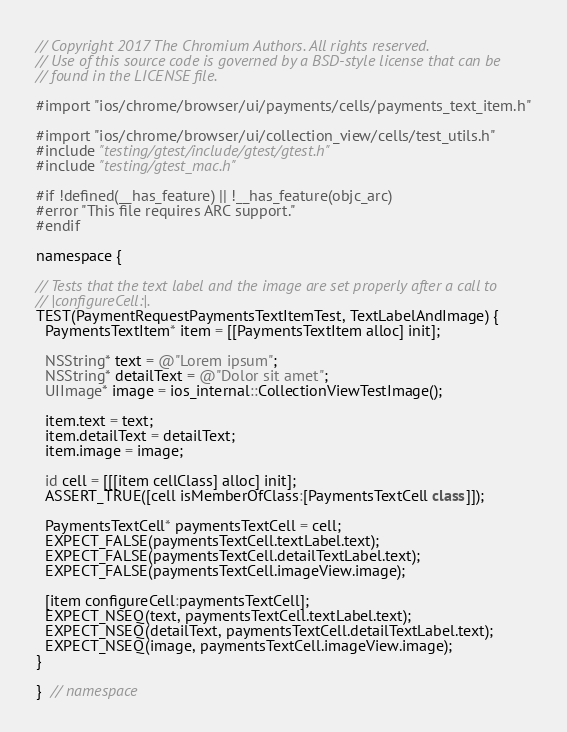Convert code to text. <code><loc_0><loc_0><loc_500><loc_500><_ObjectiveC_>// Copyright 2017 The Chromium Authors. All rights reserved.
// Use of this source code is governed by a BSD-style license that can be
// found in the LICENSE file.

#import "ios/chrome/browser/ui/payments/cells/payments_text_item.h"

#import "ios/chrome/browser/ui/collection_view/cells/test_utils.h"
#include "testing/gtest/include/gtest/gtest.h"
#include "testing/gtest_mac.h"

#if !defined(__has_feature) || !__has_feature(objc_arc)
#error "This file requires ARC support."
#endif

namespace {

// Tests that the text label and the image are set properly after a call to
// |configureCell:|.
TEST(PaymentRequestPaymentsTextItemTest, TextLabelAndImage) {
  PaymentsTextItem* item = [[PaymentsTextItem alloc] init];

  NSString* text = @"Lorem ipsum";
  NSString* detailText = @"Dolor sit amet";
  UIImage* image = ios_internal::CollectionViewTestImage();

  item.text = text;
  item.detailText = detailText;
  item.image = image;

  id cell = [[[item cellClass] alloc] init];
  ASSERT_TRUE([cell isMemberOfClass:[PaymentsTextCell class]]);

  PaymentsTextCell* paymentsTextCell = cell;
  EXPECT_FALSE(paymentsTextCell.textLabel.text);
  EXPECT_FALSE(paymentsTextCell.detailTextLabel.text);
  EXPECT_FALSE(paymentsTextCell.imageView.image);

  [item configureCell:paymentsTextCell];
  EXPECT_NSEQ(text, paymentsTextCell.textLabel.text);
  EXPECT_NSEQ(detailText, paymentsTextCell.detailTextLabel.text);
  EXPECT_NSEQ(image, paymentsTextCell.imageView.image);
}

}  // namespace
</code> 